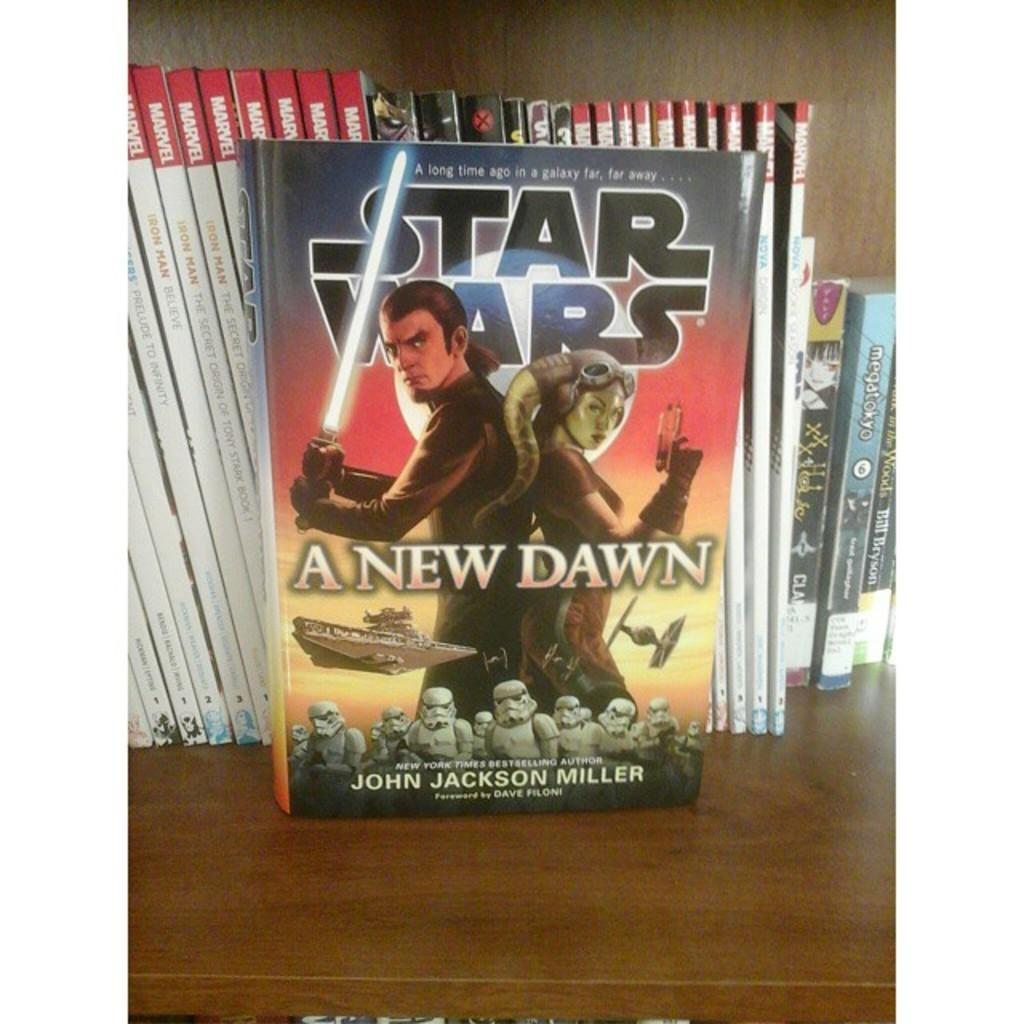<image>
Describe the image concisely. A book that is titled Star Wars: A New Dawn. 